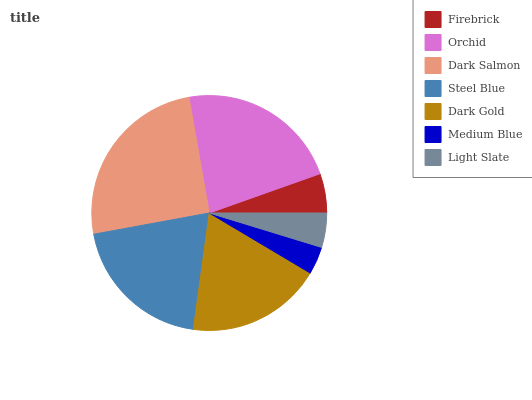Is Medium Blue the minimum?
Answer yes or no. Yes. Is Dark Salmon the maximum?
Answer yes or no. Yes. Is Orchid the minimum?
Answer yes or no. No. Is Orchid the maximum?
Answer yes or no. No. Is Orchid greater than Firebrick?
Answer yes or no. Yes. Is Firebrick less than Orchid?
Answer yes or no. Yes. Is Firebrick greater than Orchid?
Answer yes or no. No. Is Orchid less than Firebrick?
Answer yes or no. No. Is Dark Gold the high median?
Answer yes or no. Yes. Is Dark Gold the low median?
Answer yes or no. Yes. Is Light Slate the high median?
Answer yes or no. No. Is Steel Blue the low median?
Answer yes or no. No. 